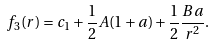Convert formula to latex. <formula><loc_0><loc_0><loc_500><loc_500>f _ { 3 } ( r ) = c _ { 1 } + \frac { 1 } { 2 } A ( 1 + a ) + \frac { 1 } { 2 } \frac { B a } { r ^ { 2 } } .</formula> 